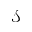Convert formula to latex. <formula><loc_0><loc_0><loc_500><loc_500>\mathcal { S }</formula> 